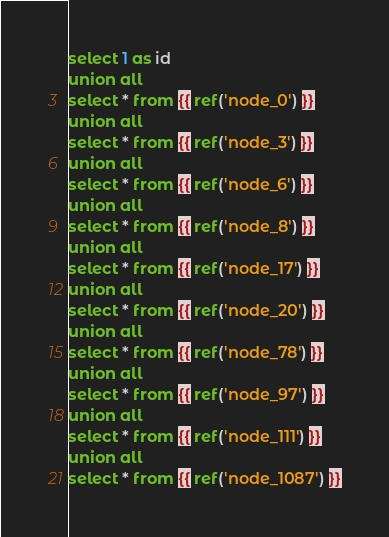Convert code to text. <code><loc_0><loc_0><loc_500><loc_500><_SQL_>select 1 as id
union all
select * from {{ ref('node_0') }}
union all
select * from {{ ref('node_3') }}
union all
select * from {{ ref('node_6') }}
union all
select * from {{ ref('node_8') }}
union all
select * from {{ ref('node_17') }}
union all
select * from {{ ref('node_20') }}
union all
select * from {{ ref('node_78') }}
union all
select * from {{ ref('node_97') }}
union all
select * from {{ ref('node_111') }}
union all
select * from {{ ref('node_1087') }}</code> 